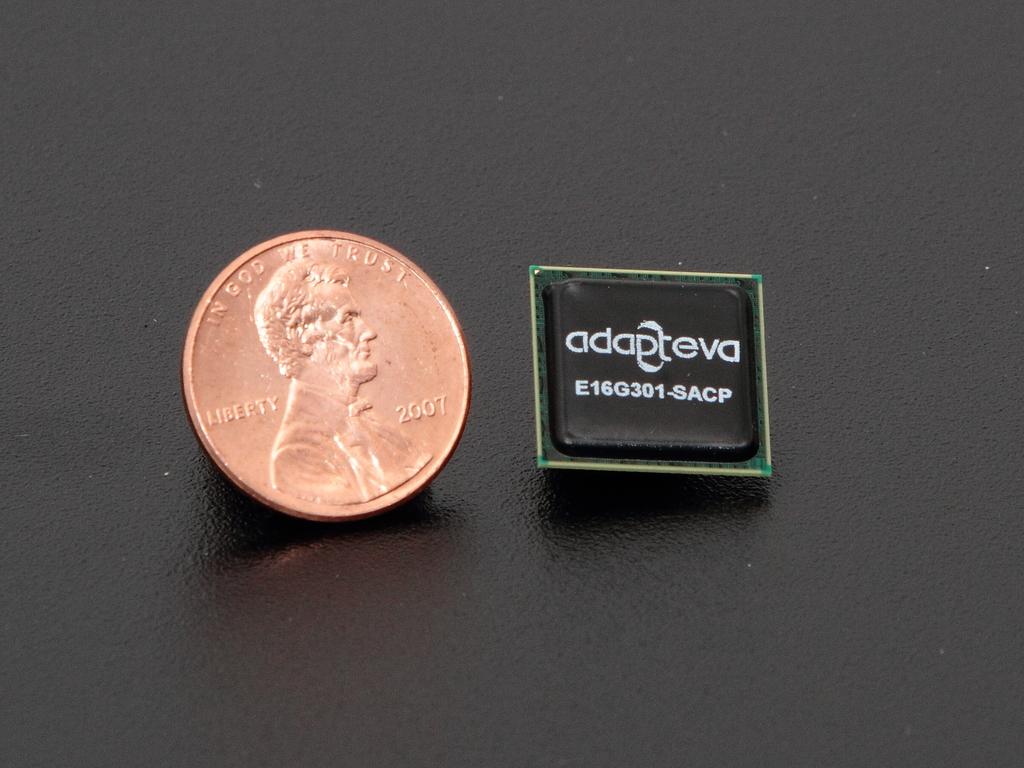In whom do we trust?
Ensure brevity in your answer.  God. What year is the penny?
Ensure brevity in your answer.  2007. 